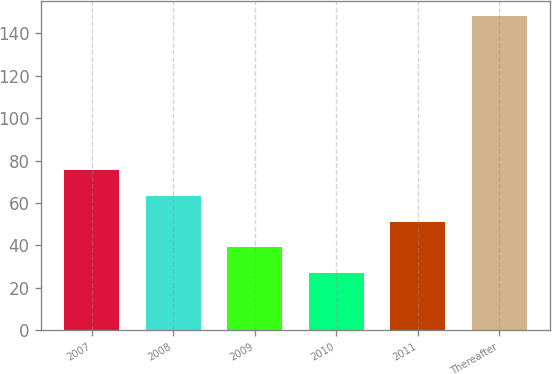Convert chart to OTSL. <chart><loc_0><loc_0><loc_500><loc_500><bar_chart><fcel>2007<fcel>2008<fcel>2009<fcel>2010<fcel>2011<fcel>Thereafter<nl><fcel>75.4<fcel>63.3<fcel>39.1<fcel>27<fcel>51.2<fcel>148<nl></chart> 